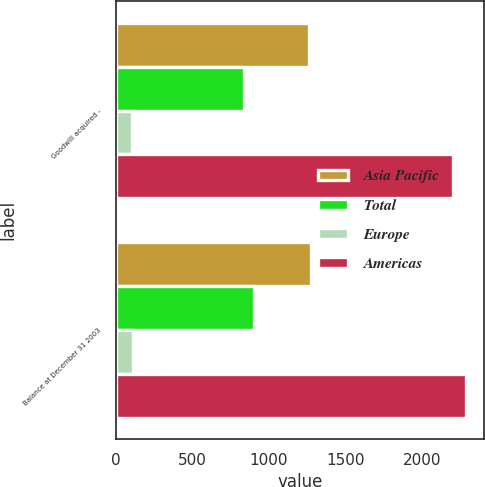Convert chart to OTSL. <chart><loc_0><loc_0><loc_500><loc_500><stacked_bar_chart><ecel><fcel>Goodwill acquired -<fcel>Balance at December 31 2003<nl><fcel>Asia Pacific<fcel>1263.6<fcel>1275.5<nl><fcel>Total<fcel>836.3<fcel>906<nl><fcel>Europe<fcel>104.8<fcel>110.3<nl><fcel>Americas<fcel>2204.7<fcel>2291.8<nl></chart> 